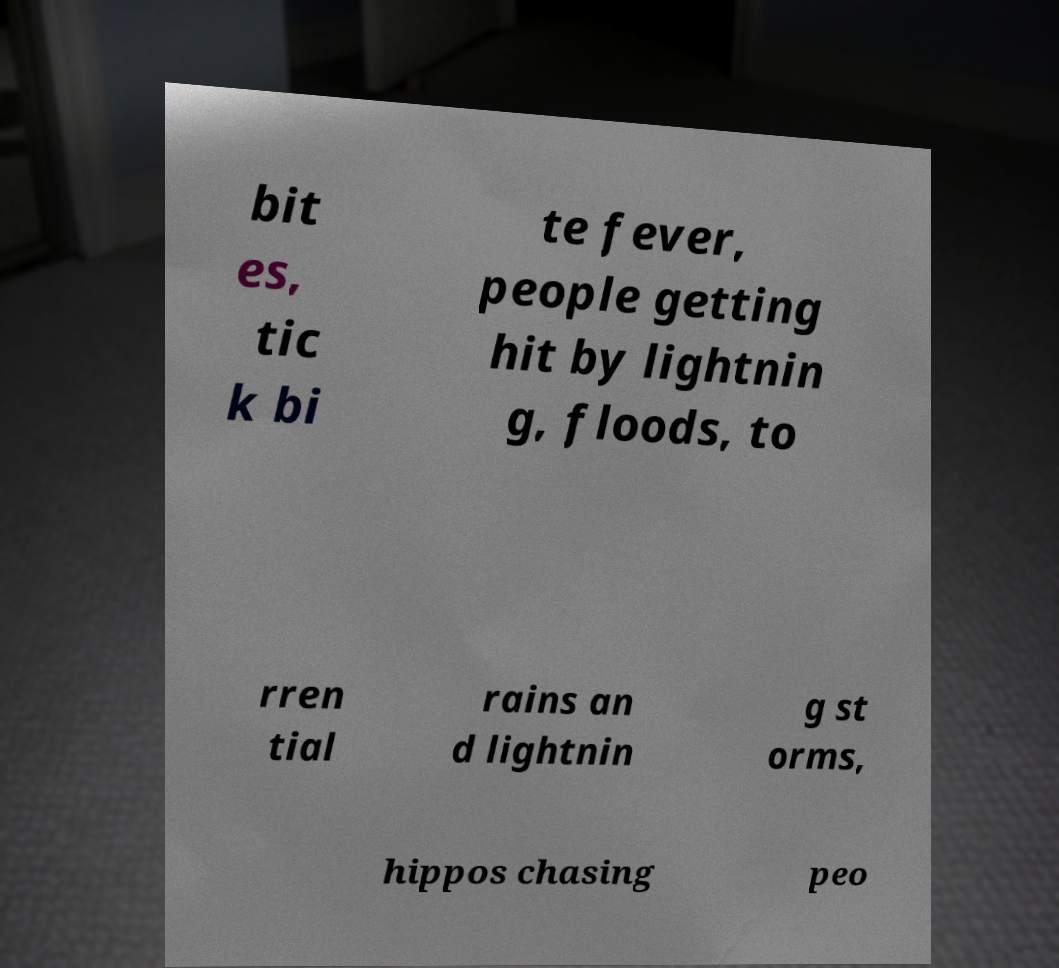Please read and relay the text visible in this image. What does it say? bit es, tic k bi te fever, people getting hit by lightnin g, floods, to rren tial rains an d lightnin g st orms, hippos chasing peo 